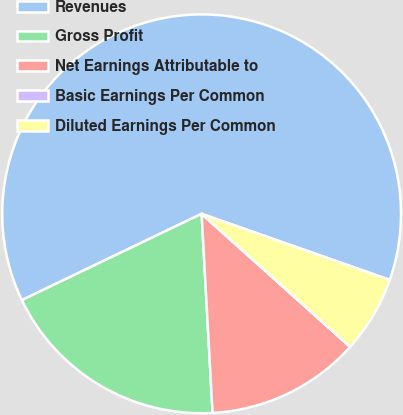Convert chart to OTSL. <chart><loc_0><loc_0><loc_500><loc_500><pie_chart><fcel>Revenues<fcel>Gross Profit<fcel>Net Earnings Attributable to<fcel>Basic Earnings Per Common<fcel>Diluted Earnings Per Common<nl><fcel>62.5%<fcel>18.75%<fcel>12.5%<fcel>0.0%<fcel>6.25%<nl></chart> 